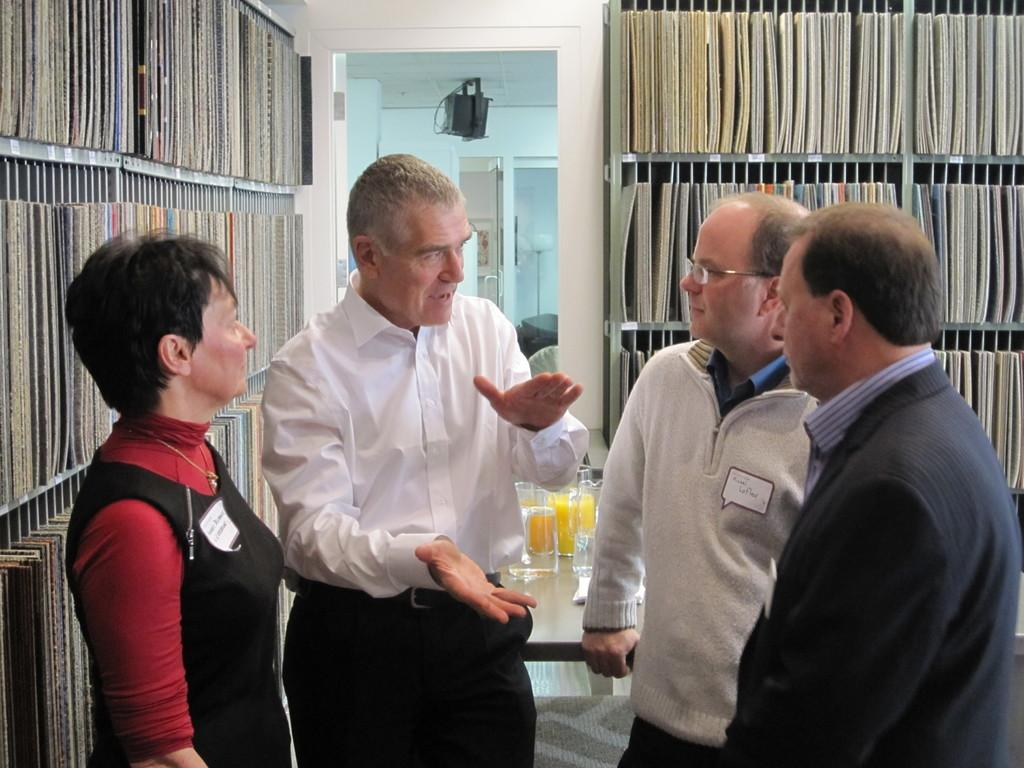How many people are in the image? There are three men and a woman standing in the image, making a total of four people. What can be seen in the background of the image? There are books placed on racks in the background. What part of the room is visible in the image? The ceiling is visible in the image. What is on the ceiling? There is a light on the ceiling. Where is the hen located in the image? There is no hen present in the image. What type of flooring can be seen in the image? The provided facts do not mention the flooring, so it cannot be determined from the image. 